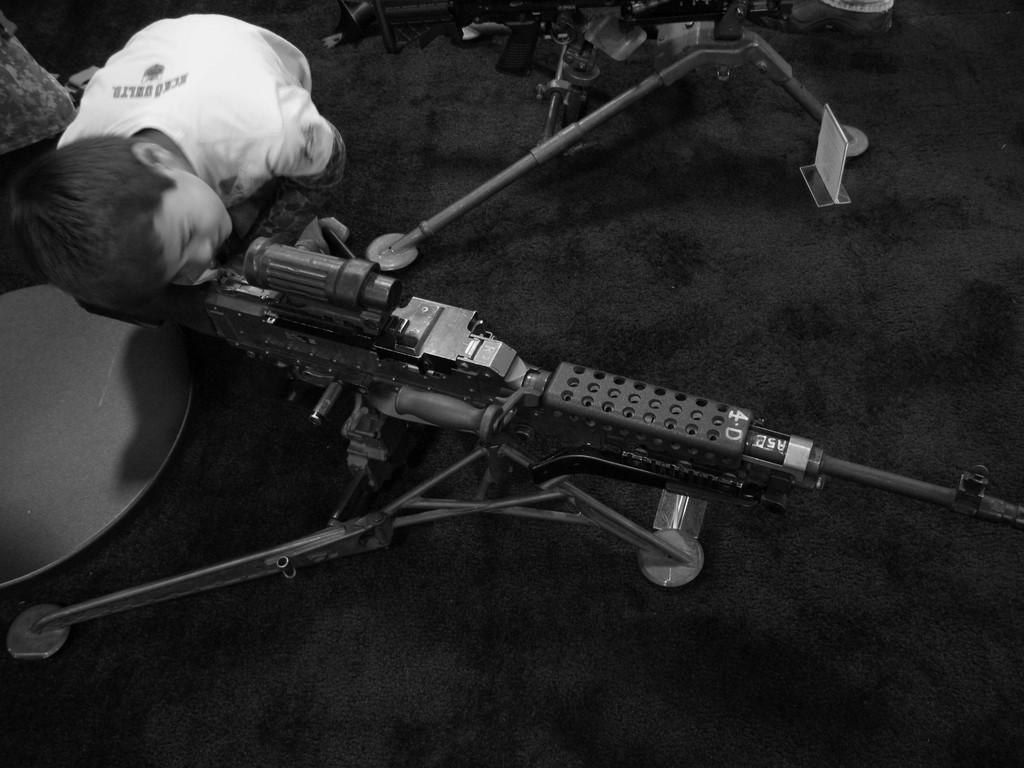What is the main subject of the image? The main subject of the image is a kid. What is the kid doing in the image? The kid is standing and peeking through a riffle. How is the riffle positioned in the image? The riffle is kept on a stand. What is the color scheme of the image? The image is in black and white color. What type of hydrant can be seen in the background of the image? There is no hydrant present in the image. Is there a turkey roasting on a board in the image? There is no turkey or board present in the image. 